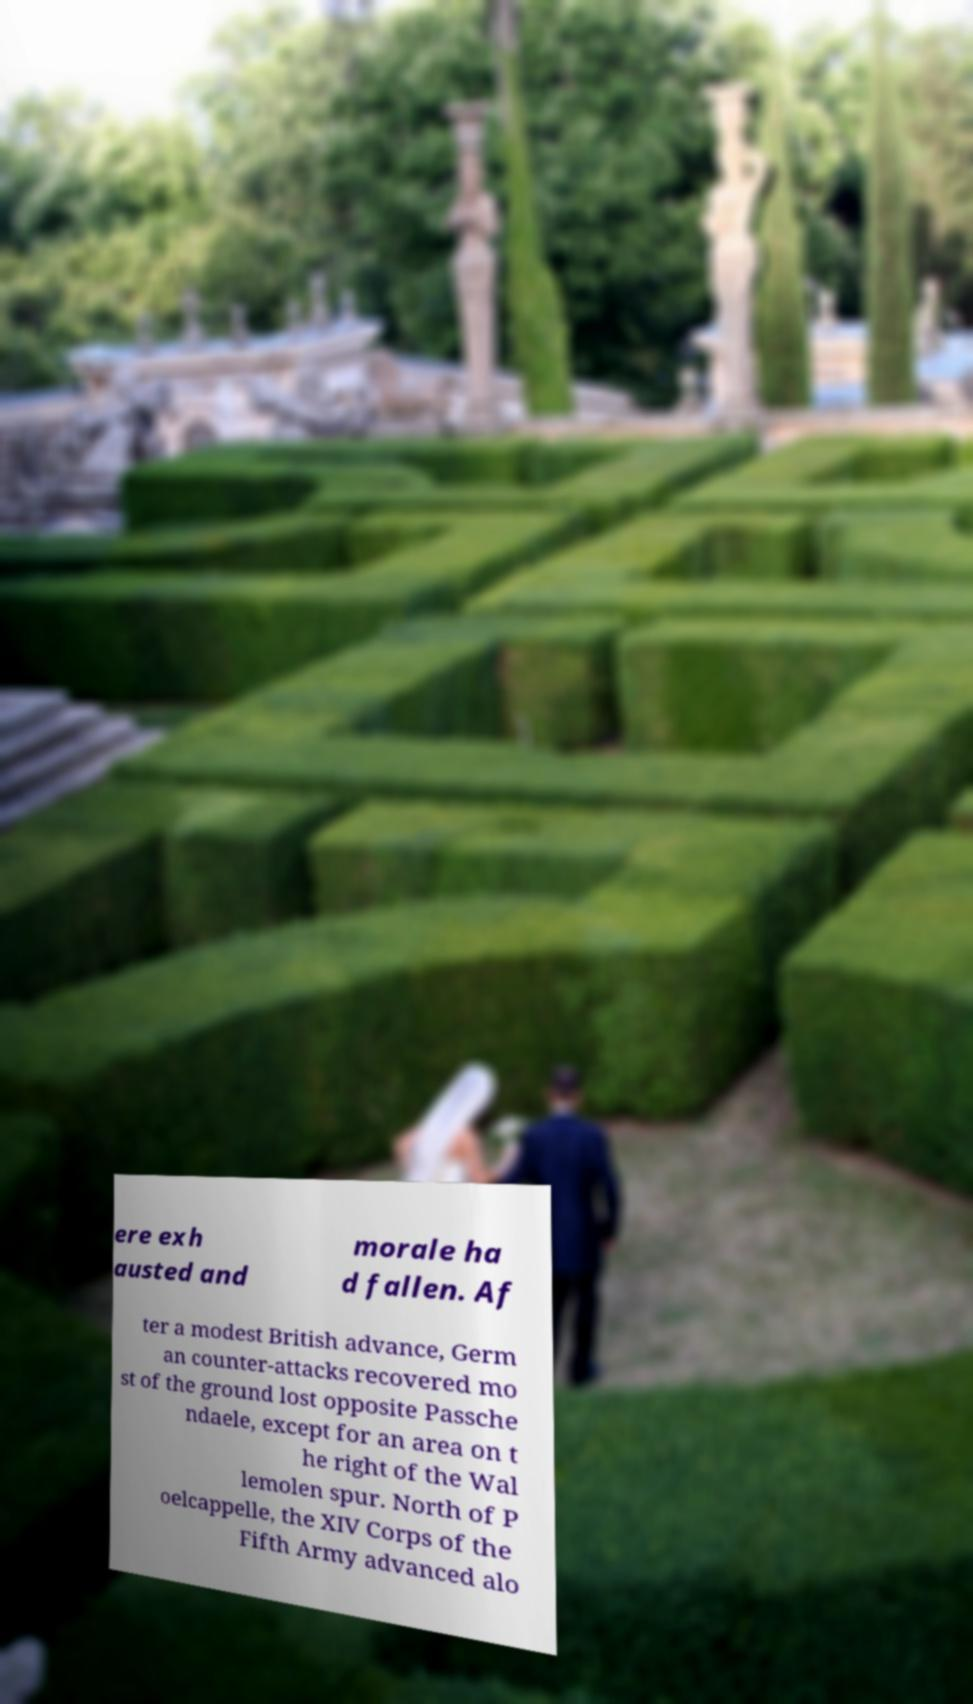What messages or text are displayed in this image? I need them in a readable, typed format. ere exh austed and morale ha d fallen. Af ter a modest British advance, Germ an counter-attacks recovered mo st of the ground lost opposite Passche ndaele, except for an area on t he right of the Wal lemolen spur. North of P oelcappelle, the XIV Corps of the Fifth Army advanced alo 